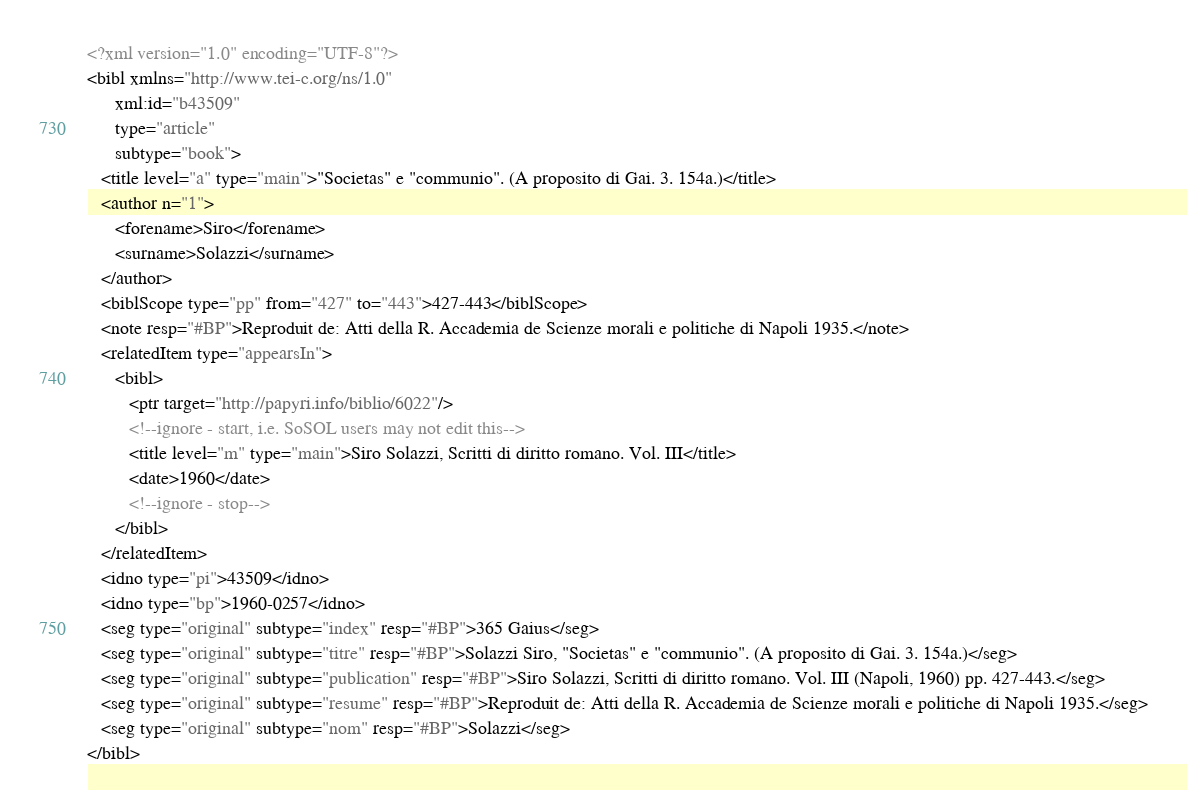<code> <loc_0><loc_0><loc_500><loc_500><_XML_><?xml version="1.0" encoding="UTF-8"?>
<bibl xmlns="http://www.tei-c.org/ns/1.0"
      xml:id="b43509"
      type="article"
      subtype="book">
   <title level="a" type="main">"Societas" e "communio". (A proposito di Gai. 3. 154a.)</title>
   <author n="1">
      <forename>Siro</forename>
      <surname>Solazzi</surname>
   </author>
   <biblScope type="pp" from="427" to="443">427-443</biblScope>
   <note resp="#BP">Reproduit de: Atti della R. Accademia de Scienze morali e politiche di Napoli 1935.</note>
   <relatedItem type="appearsIn">
      <bibl>
         <ptr target="http://papyri.info/biblio/6022"/>
         <!--ignore - start, i.e. SoSOL users may not edit this-->
         <title level="m" type="main">Siro Solazzi, Scritti di diritto romano. Vol. III</title>
         <date>1960</date>
         <!--ignore - stop-->
      </bibl>
   </relatedItem>
   <idno type="pi">43509</idno>
   <idno type="bp">1960-0257</idno>
   <seg type="original" subtype="index" resp="#BP">365 Gaius</seg>
   <seg type="original" subtype="titre" resp="#BP">Solazzi Siro, "Societas" e "communio". (A proposito di Gai. 3. 154a.)</seg>
   <seg type="original" subtype="publication" resp="#BP">Siro Solazzi, Scritti di diritto romano. Vol. III (Napoli, 1960) pp. 427-443.</seg>
   <seg type="original" subtype="resume" resp="#BP">Reproduit de: Atti della R. Accademia de Scienze morali e politiche di Napoli 1935.</seg>
   <seg type="original" subtype="nom" resp="#BP">Solazzi</seg>
</bibl>
</code> 